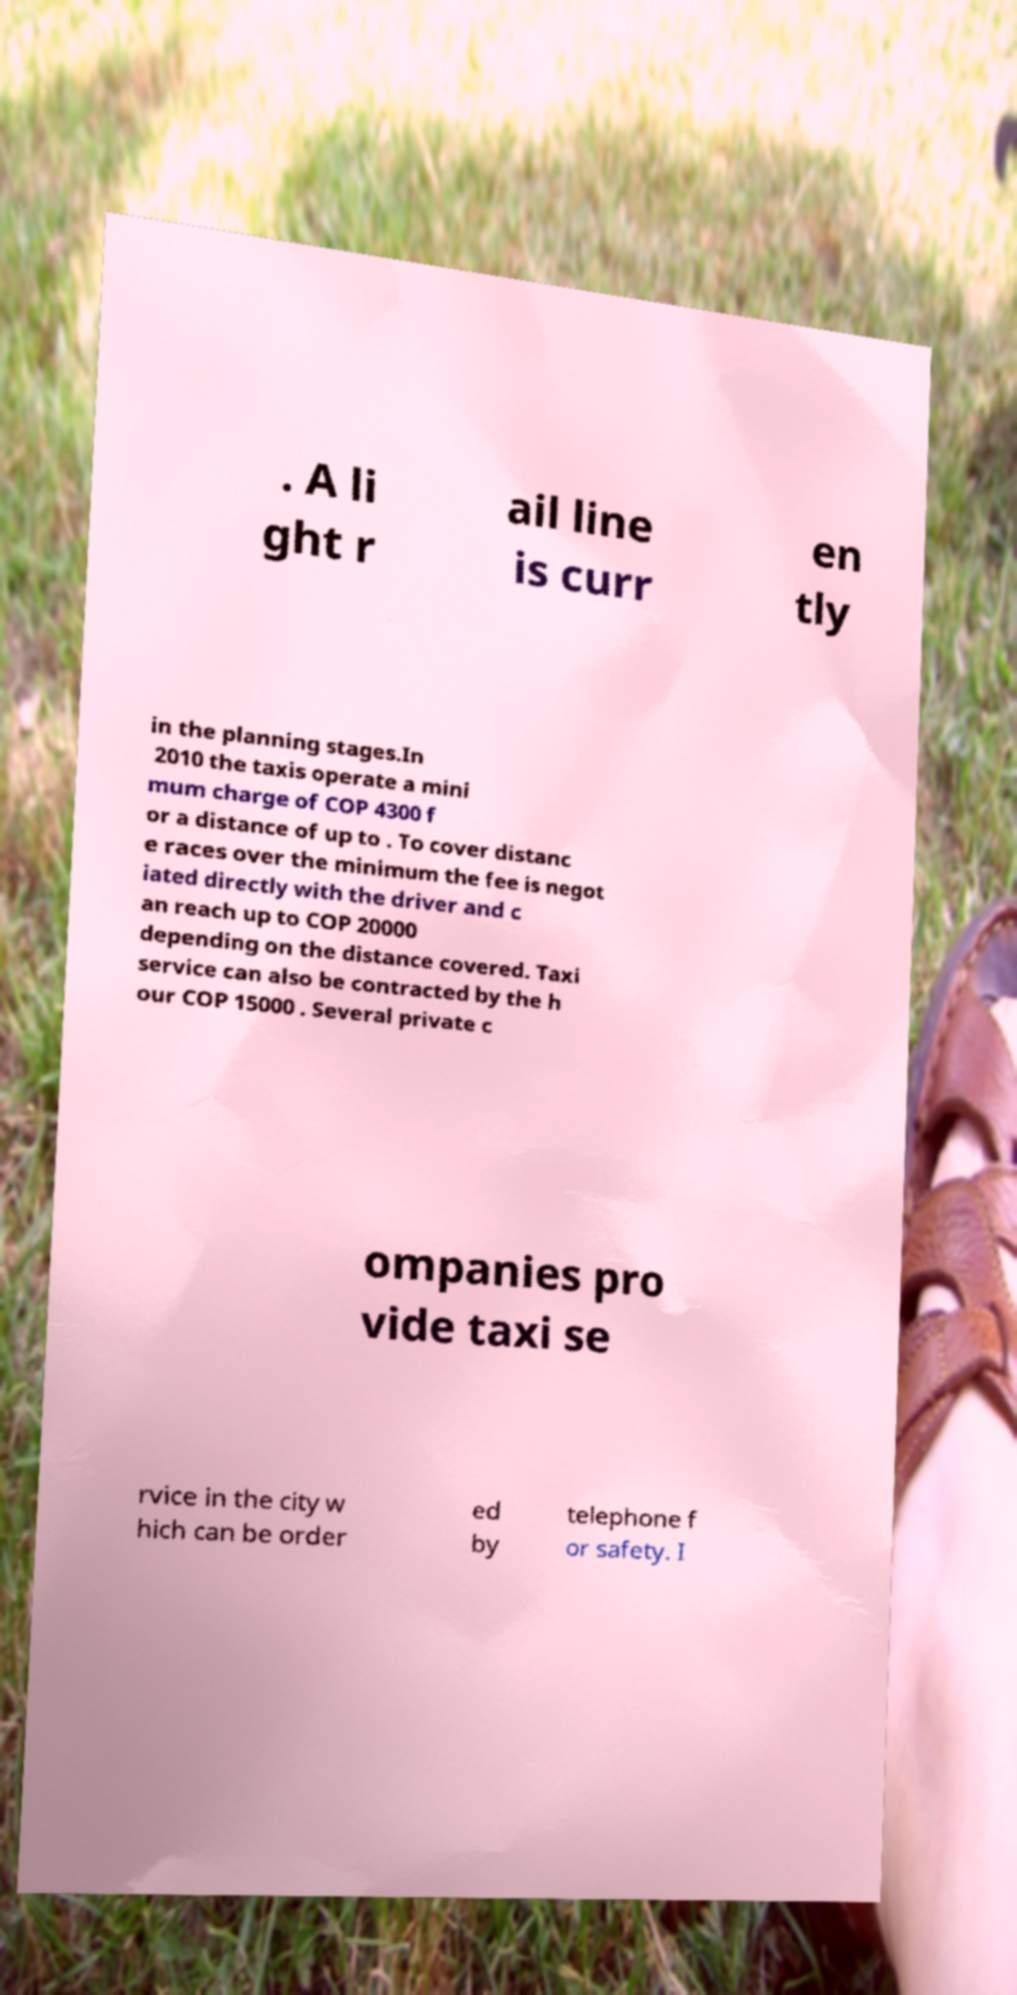There's text embedded in this image that I need extracted. Can you transcribe it verbatim? . A li ght r ail line is curr en tly in the planning stages.In 2010 the taxis operate a mini mum charge of COP 4300 f or a distance of up to . To cover distanc e races over the minimum the fee is negot iated directly with the driver and c an reach up to COP 20000 depending on the distance covered. Taxi service can also be contracted by the h our COP 15000 . Several private c ompanies pro vide taxi se rvice in the city w hich can be order ed by telephone f or safety. I 